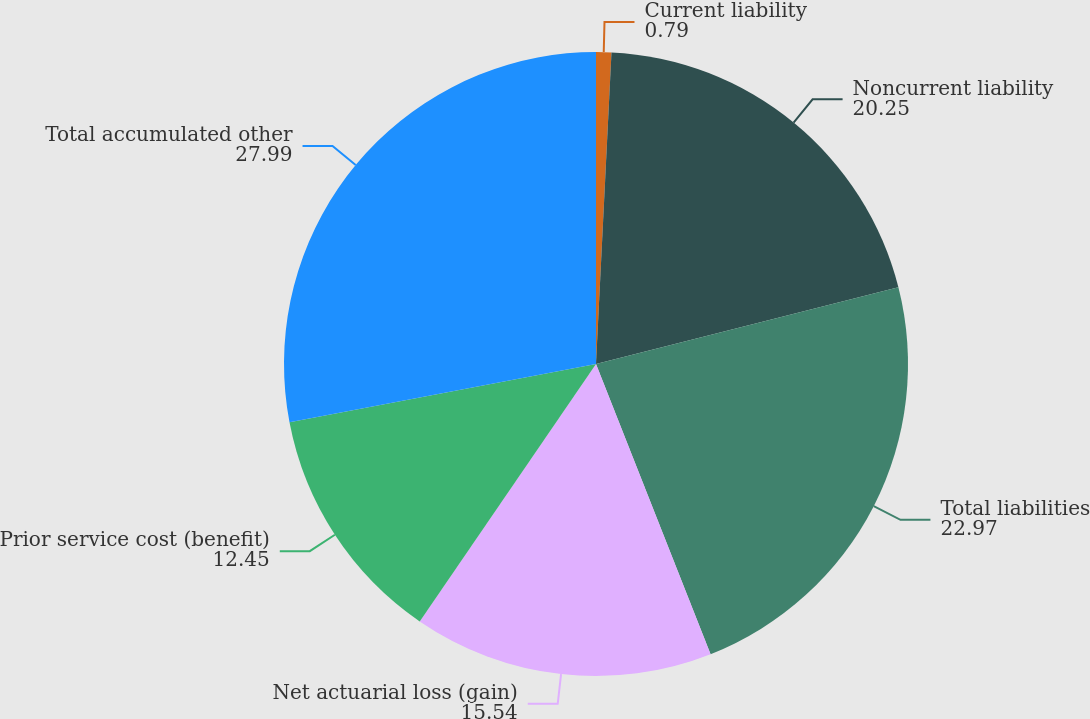<chart> <loc_0><loc_0><loc_500><loc_500><pie_chart><fcel>Current liability<fcel>Noncurrent liability<fcel>Total liabilities<fcel>Net actuarial loss (gain)<fcel>Prior service cost (benefit)<fcel>Total accumulated other<nl><fcel>0.79%<fcel>20.25%<fcel>22.97%<fcel>15.54%<fcel>12.45%<fcel>27.99%<nl></chart> 